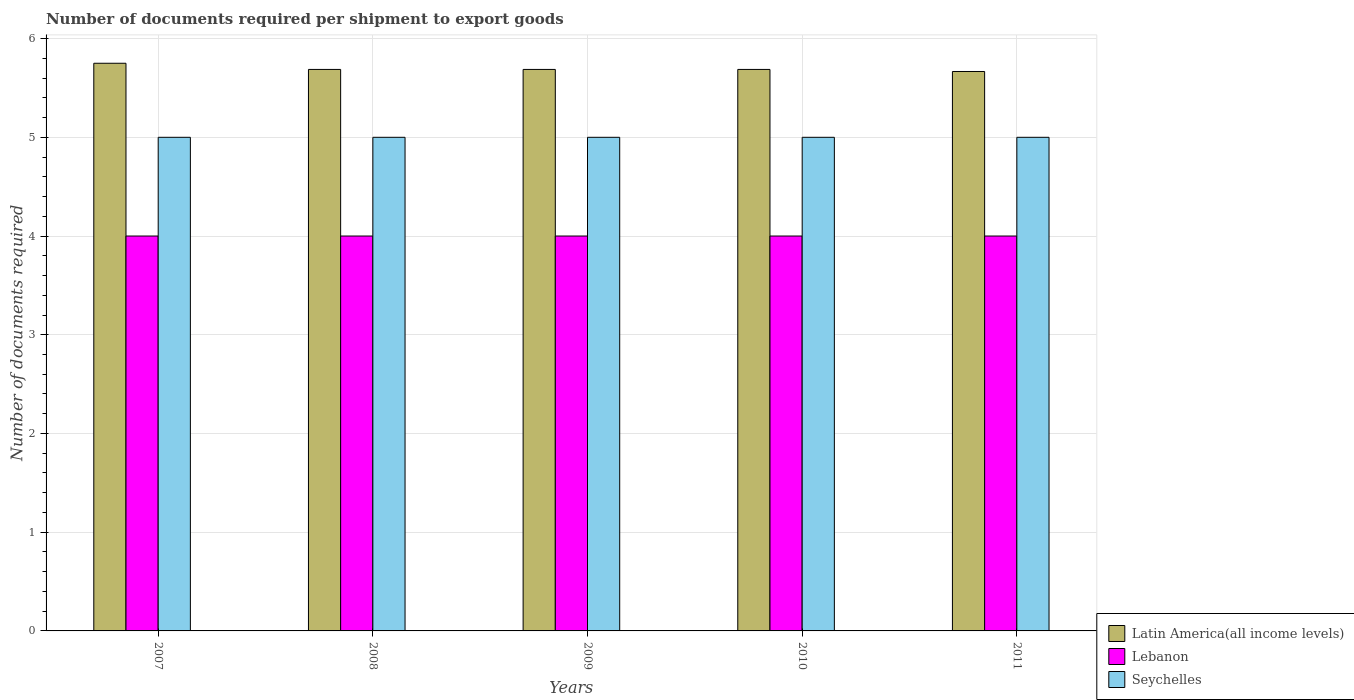Are the number of bars on each tick of the X-axis equal?
Provide a short and direct response. Yes. How many bars are there on the 4th tick from the left?
Ensure brevity in your answer.  3. How many bars are there on the 3rd tick from the right?
Offer a very short reply. 3. What is the label of the 3rd group of bars from the left?
Offer a very short reply. 2009. In how many cases, is the number of bars for a given year not equal to the number of legend labels?
Provide a succinct answer. 0. What is the number of documents required per shipment to export goods in Seychelles in 2010?
Give a very brief answer. 5. Across all years, what is the maximum number of documents required per shipment to export goods in Lebanon?
Keep it short and to the point. 4. Across all years, what is the minimum number of documents required per shipment to export goods in Seychelles?
Your response must be concise. 5. In which year was the number of documents required per shipment to export goods in Latin America(all income levels) maximum?
Keep it short and to the point. 2007. What is the total number of documents required per shipment to export goods in Seychelles in the graph?
Keep it short and to the point. 25. What is the difference between the number of documents required per shipment to export goods in Seychelles in 2011 and the number of documents required per shipment to export goods in Lebanon in 2010?
Keep it short and to the point. 1. In the year 2010, what is the difference between the number of documents required per shipment to export goods in Seychelles and number of documents required per shipment to export goods in Lebanon?
Provide a succinct answer. 1. In how many years, is the number of documents required per shipment to export goods in Seychelles greater than 2.2?
Your response must be concise. 5. Is the number of documents required per shipment to export goods in Lebanon in 2007 less than that in 2010?
Provide a succinct answer. No. Is the difference between the number of documents required per shipment to export goods in Seychelles in 2007 and 2008 greater than the difference between the number of documents required per shipment to export goods in Lebanon in 2007 and 2008?
Give a very brief answer. No. What is the difference between the highest and the lowest number of documents required per shipment to export goods in Lebanon?
Offer a terse response. 0. In how many years, is the number of documents required per shipment to export goods in Lebanon greater than the average number of documents required per shipment to export goods in Lebanon taken over all years?
Offer a very short reply. 0. Is the sum of the number of documents required per shipment to export goods in Seychelles in 2008 and 2009 greater than the maximum number of documents required per shipment to export goods in Latin America(all income levels) across all years?
Your answer should be compact. Yes. What does the 2nd bar from the left in 2008 represents?
Make the answer very short. Lebanon. What does the 1st bar from the right in 2010 represents?
Keep it short and to the point. Seychelles. Is it the case that in every year, the sum of the number of documents required per shipment to export goods in Latin America(all income levels) and number of documents required per shipment to export goods in Lebanon is greater than the number of documents required per shipment to export goods in Seychelles?
Ensure brevity in your answer.  Yes. Are all the bars in the graph horizontal?
Provide a succinct answer. No. Are the values on the major ticks of Y-axis written in scientific E-notation?
Keep it short and to the point. No. Where does the legend appear in the graph?
Give a very brief answer. Bottom right. How many legend labels are there?
Make the answer very short. 3. How are the legend labels stacked?
Your answer should be very brief. Vertical. What is the title of the graph?
Ensure brevity in your answer.  Number of documents required per shipment to export goods. What is the label or title of the X-axis?
Keep it short and to the point. Years. What is the label or title of the Y-axis?
Your answer should be compact. Number of documents required. What is the Number of documents required of Latin America(all income levels) in 2007?
Give a very brief answer. 5.75. What is the Number of documents required in Lebanon in 2007?
Give a very brief answer. 4. What is the Number of documents required of Seychelles in 2007?
Keep it short and to the point. 5. What is the Number of documents required in Latin America(all income levels) in 2008?
Make the answer very short. 5.69. What is the Number of documents required in Latin America(all income levels) in 2009?
Ensure brevity in your answer.  5.69. What is the Number of documents required in Latin America(all income levels) in 2010?
Offer a terse response. 5.69. What is the Number of documents required in Latin America(all income levels) in 2011?
Ensure brevity in your answer.  5.67. What is the Number of documents required in Lebanon in 2011?
Ensure brevity in your answer.  4. Across all years, what is the maximum Number of documents required of Latin America(all income levels)?
Your answer should be compact. 5.75. Across all years, what is the maximum Number of documents required in Lebanon?
Keep it short and to the point. 4. Across all years, what is the maximum Number of documents required of Seychelles?
Your answer should be very brief. 5. Across all years, what is the minimum Number of documents required of Latin America(all income levels)?
Your answer should be compact. 5.67. What is the total Number of documents required in Latin America(all income levels) in the graph?
Offer a terse response. 28.48. What is the difference between the Number of documents required of Latin America(all income levels) in 2007 and that in 2008?
Keep it short and to the point. 0.06. What is the difference between the Number of documents required of Lebanon in 2007 and that in 2008?
Offer a terse response. 0. What is the difference between the Number of documents required in Latin America(all income levels) in 2007 and that in 2009?
Your answer should be very brief. 0.06. What is the difference between the Number of documents required of Seychelles in 2007 and that in 2009?
Keep it short and to the point. 0. What is the difference between the Number of documents required in Latin America(all income levels) in 2007 and that in 2010?
Provide a succinct answer. 0.06. What is the difference between the Number of documents required in Latin America(all income levels) in 2007 and that in 2011?
Ensure brevity in your answer.  0.08. What is the difference between the Number of documents required of Latin America(all income levels) in 2008 and that in 2010?
Make the answer very short. 0. What is the difference between the Number of documents required of Latin America(all income levels) in 2008 and that in 2011?
Your response must be concise. 0.02. What is the difference between the Number of documents required in Lebanon in 2008 and that in 2011?
Your response must be concise. 0. What is the difference between the Number of documents required in Seychelles in 2008 and that in 2011?
Offer a very short reply. 0. What is the difference between the Number of documents required in Latin America(all income levels) in 2009 and that in 2010?
Your response must be concise. 0. What is the difference between the Number of documents required in Latin America(all income levels) in 2009 and that in 2011?
Your answer should be compact. 0.02. What is the difference between the Number of documents required in Latin America(all income levels) in 2010 and that in 2011?
Your answer should be compact. 0.02. What is the difference between the Number of documents required of Lebanon in 2010 and that in 2011?
Give a very brief answer. 0. What is the difference between the Number of documents required in Seychelles in 2010 and that in 2011?
Keep it short and to the point. 0. What is the difference between the Number of documents required in Latin America(all income levels) in 2007 and the Number of documents required in Seychelles in 2008?
Offer a very short reply. 0.75. What is the difference between the Number of documents required in Lebanon in 2007 and the Number of documents required in Seychelles in 2008?
Keep it short and to the point. -1. What is the difference between the Number of documents required of Latin America(all income levels) in 2007 and the Number of documents required of Seychelles in 2009?
Keep it short and to the point. 0.75. What is the difference between the Number of documents required of Lebanon in 2007 and the Number of documents required of Seychelles in 2009?
Make the answer very short. -1. What is the difference between the Number of documents required of Latin America(all income levels) in 2007 and the Number of documents required of Lebanon in 2011?
Give a very brief answer. 1.75. What is the difference between the Number of documents required of Latin America(all income levels) in 2008 and the Number of documents required of Lebanon in 2009?
Your answer should be very brief. 1.69. What is the difference between the Number of documents required of Latin America(all income levels) in 2008 and the Number of documents required of Seychelles in 2009?
Ensure brevity in your answer.  0.69. What is the difference between the Number of documents required in Lebanon in 2008 and the Number of documents required in Seychelles in 2009?
Provide a succinct answer. -1. What is the difference between the Number of documents required in Latin America(all income levels) in 2008 and the Number of documents required in Lebanon in 2010?
Ensure brevity in your answer.  1.69. What is the difference between the Number of documents required in Latin America(all income levels) in 2008 and the Number of documents required in Seychelles in 2010?
Make the answer very short. 0.69. What is the difference between the Number of documents required of Lebanon in 2008 and the Number of documents required of Seychelles in 2010?
Give a very brief answer. -1. What is the difference between the Number of documents required of Latin America(all income levels) in 2008 and the Number of documents required of Lebanon in 2011?
Offer a terse response. 1.69. What is the difference between the Number of documents required in Latin America(all income levels) in 2008 and the Number of documents required in Seychelles in 2011?
Make the answer very short. 0.69. What is the difference between the Number of documents required of Lebanon in 2008 and the Number of documents required of Seychelles in 2011?
Keep it short and to the point. -1. What is the difference between the Number of documents required in Latin America(all income levels) in 2009 and the Number of documents required in Lebanon in 2010?
Offer a terse response. 1.69. What is the difference between the Number of documents required of Latin America(all income levels) in 2009 and the Number of documents required of Seychelles in 2010?
Make the answer very short. 0.69. What is the difference between the Number of documents required of Lebanon in 2009 and the Number of documents required of Seychelles in 2010?
Provide a succinct answer. -1. What is the difference between the Number of documents required of Latin America(all income levels) in 2009 and the Number of documents required of Lebanon in 2011?
Ensure brevity in your answer.  1.69. What is the difference between the Number of documents required in Latin America(all income levels) in 2009 and the Number of documents required in Seychelles in 2011?
Offer a terse response. 0.69. What is the difference between the Number of documents required of Latin America(all income levels) in 2010 and the Number of documents required of Lebanon in 2011?
Give a very brief answer. 1.69. What is the difference between the Number of documents required of Latin America(all income levels) in 2010 and the Number of documents required of Seychelles in 2011?
Your response must be concise. 0.69. What is the difference between the Number of documents required of Lebanon in 2010 and the Number of documents required of Seychelles in 2011?
Keep it short and to the point. -1. What is the average Number of documents required in Latin America(all income levels) per year?
Keep it short and to the point. 5.7. What is the average Number of documents required of Seychelles per year?
Give a very brief answer. 5. In the year 2007, what is the difference between the Number of documents required of Lebanon and Number of documents required of Seychelles?
Provide a short and direct response. -1. In the year 2008, what is the difference between the Number of documents required of Latin America(all income levels) and Number of documents required of Lebanon?
Offer a terse response. 1.69. In the year 2008, what is the difference between the Number of documents required in Latin America(all income levels) and Number of documents required in Seychelles?
Keep it short and to the point. 0.69. In the year 2009, what is the difference between the Number of documents required in Latin America(all income levels) and Number of documents required in Lebanon?
Give a very brief answer. 1.69. In the year 2009, what is the difference between the Number of documents required of Latin America(all income levels) and Number of documents required of Seychelles?
Make the answer very short. 0.69. In the year 2010, what is the difference between the Number of documents required in Latin America(all income levels) and Number of documents required in Lebanon?
Provide a succinct answer. 1.69. In the year 2010, what is the difference between the Number of documents required in Latin America(all income levels) and Number of documents required in Seychelles?
Ensure brevity in your answer.  0.69. In the year 2010, what is the difference between the Number of documents required of Lebanon and Number of documents required of Seychelles?
Offer a terse response. -1. In the year 2011, what is the difference between the Number of documents required in Latin America(all income levels) and Number of documents required in Seychelles?
Make the answer very short. 0.67. What is the ratio of the Number of documents required of Lebanon in 2007 to that in 2008?
Your response must be concise. 1. What is the ratio of the Number of documents required of Seychelles in 2007 to that in 2010?
Give a very brief answer. 1. What is the ratio of the Number of documents required in Latin America(all income levels) in 2007 to that in 2011?
Your answer should be compact. 1.01. What is the ratio of the Number of documents required in Lebanon in 2007 to that in 2011?
Offer a terse response. 1. What is the ratio of the Number of documents required in Latin America(all income levels) in 2008 to that in 2009?
Ensure brevity in your answer.  1. What is the ratio of the Number of documents required of Lebanon in 2008 to that in 2009?
Keep it short and to the point. 1. What is the ratio of the Number of documents required of Seychelles in 2008 to that in 2009?
Your answer should be compact. 1. What is the ratio of the Number of documents required in Latin America(all income levels) in 2008 to that in 2011?
Offer a terse response. 1. What is the ratio of the Number of documents required in Lebanon in 2008 to that in 2011?
Provide a succinct answer. 1. What is the ratio of the Number of documents required in Latin America(all income levels) in 2009 to that in 2010?
Offer a very short reply. 1. What is the ratio of the Number of documents required in Lebanon in 2009 to that in 2010?
Provide a succinct answer. 1. What is the ratio of the Number of documents required in Lebanon in 2009 to that in 2011?
Make the answer very short. 1. What is the ratio of the Number of documents required in Latin America(all income levels) in 2010 to that in 2011?
Offer a very short reply. 1. What is the ratio of the Number of documents required in Lebanon in 2010 to that in 2011?
Offer a terse response. 1. What is the difference between the highest and the second highest Number of documents required of Latin America(all income levels)?
Your answer should be compact. 0.06. What is the difference between the highest and the second highest Number of documents required in Lebanon?
Keep it short and to the point. 0. What is the difference between the highest and the second highest Number of documents required in Seychelles?
Provide a succinct answer. 0. What is the difference between the highest and the lowest Number of documents required in Latin America(all income levels)?
Give a very brief answer. 0.08. 